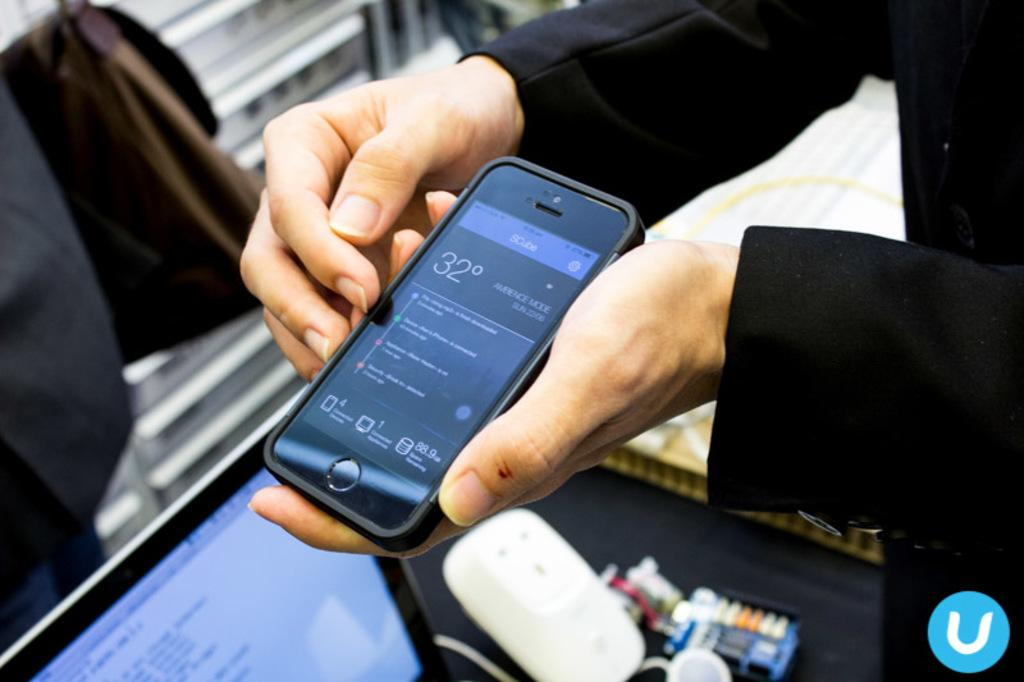<image>
Relay a brief, clear account of the picture shown. Person holding a smartphone that says 32 degrees outside. 